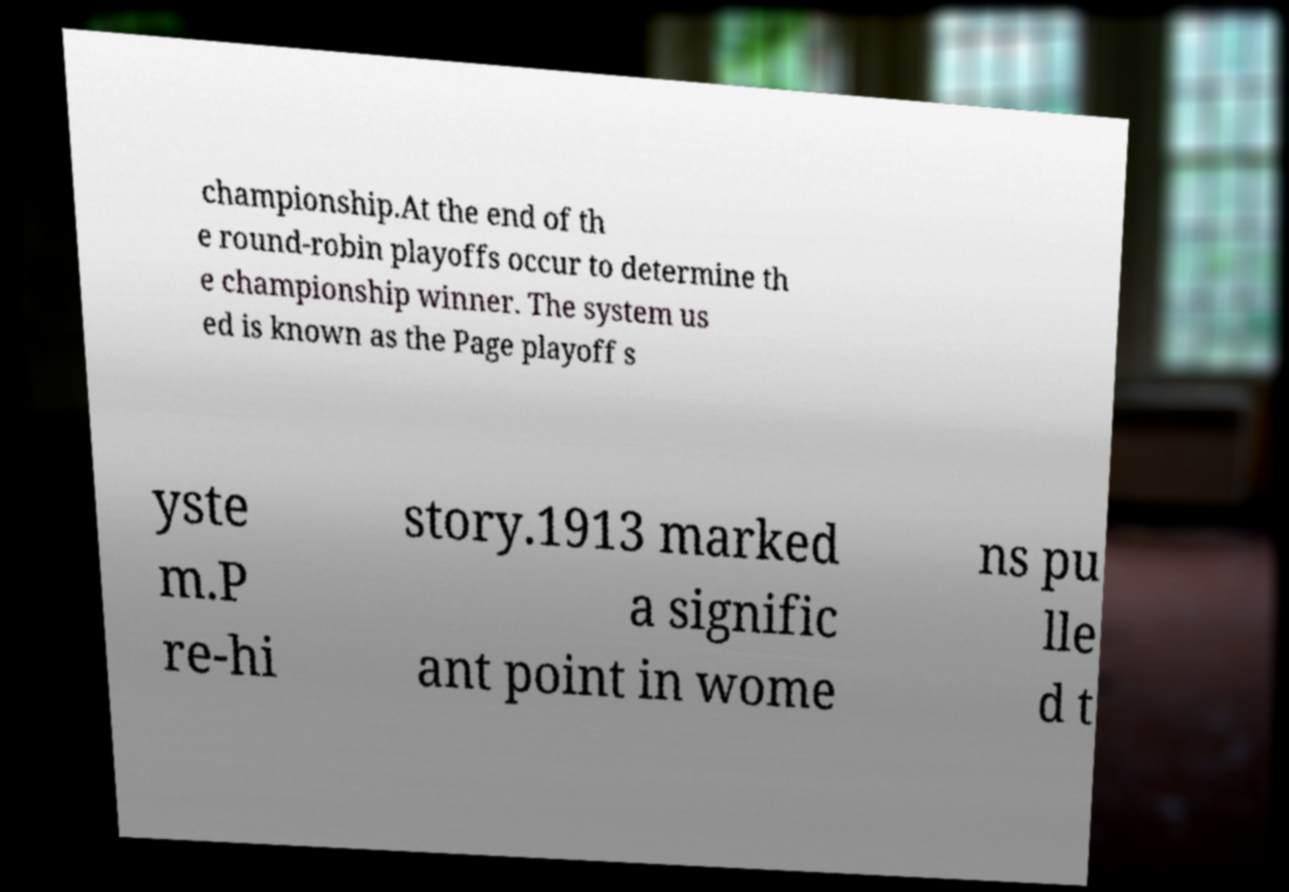Could you assist in decoding the text presented in this image and type it out clearly? championship.At the end of th e round-robin playoffs occur to determine th e championship winner. The system us ed is known as the Page playoff s yste m.P re-hi story.1913 marked a signific ant point in wome ns pu lle d t 